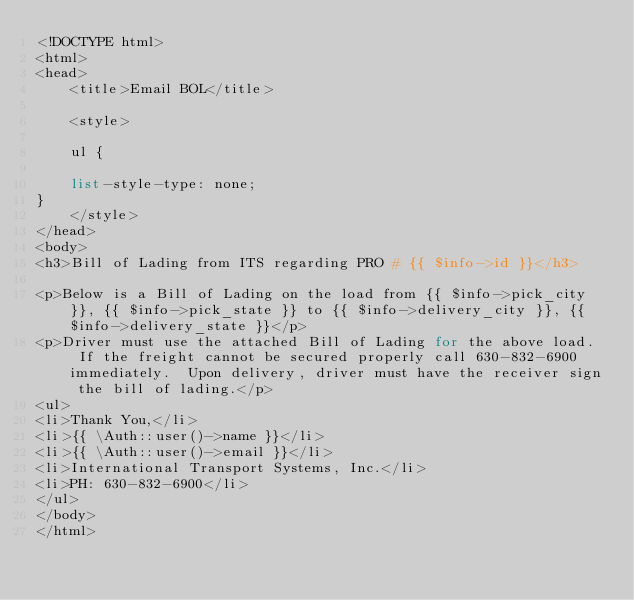Convert code to text. <code><loc_0><loc_0><loc_500><loc_500><_PHP_><!DOCTYPE html>
<html>
<head>
	<title>Email BOL</title>

	<style>

	ul {

	list-style-type: none;
}
	</style>
</head>
<body>
<h3>Bill of Lading from ITS regarding PRO # {{ $info->id }}</h3>

<p>Below is a Bill of Lading on the load from {{ $info->pick_city }}, {{ $info->pick_state }} to {{ $info->delivery_city }}, {{ $info->delivery_state }}</p>
<p>Driver must use the attached Bill of Lading for the above load.  If the freight cannot be secured properly call 630-832-6900 immediately.  Upon delivery, driver must have the receiver sign the bill of lading.</p>
<ul>
<li>Thank You,</li>
<li>{{ \Auth::user()->name }}</li>
<li>{{ \Auth::user()->email }}</li>
<li>International Transport Systems, Inc.</li>
<li>PH: 630-832-6900</li>
</ul>
</body>
</html></code> 